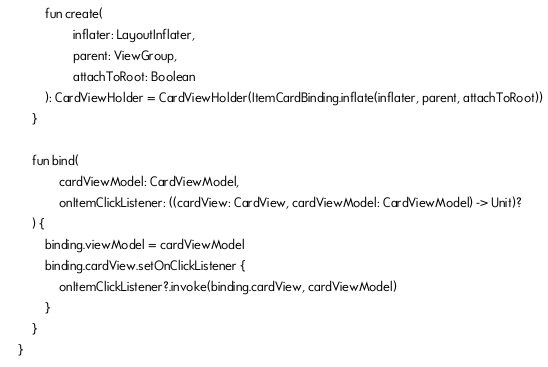Convert code to text. <code><loc_0><loc_0><loc_500><loc_500><_Kotlin_>        fun create(
                inflater: LayoutInflater,
                parent: ViewGroup,
                attachToRoot: Boolean
        ): CardViewHolder = CardViewHolder(ItemCardBinding.inflate(inflater, parent, attachToRoot))
    }

    fun bind(
            cardViewModel: CardViewModel,
            onItemClickListener: ((cardView: CardView, cardViewModel: CardViewModel) -> Unit)?
    ) {
        binding.viewModel = cardViewModel
        binding.cardView.setOnClickListener {
            onItemClickListener?.invoke(binding.cardView, cardViewModel)
        }
    }
}</code> 